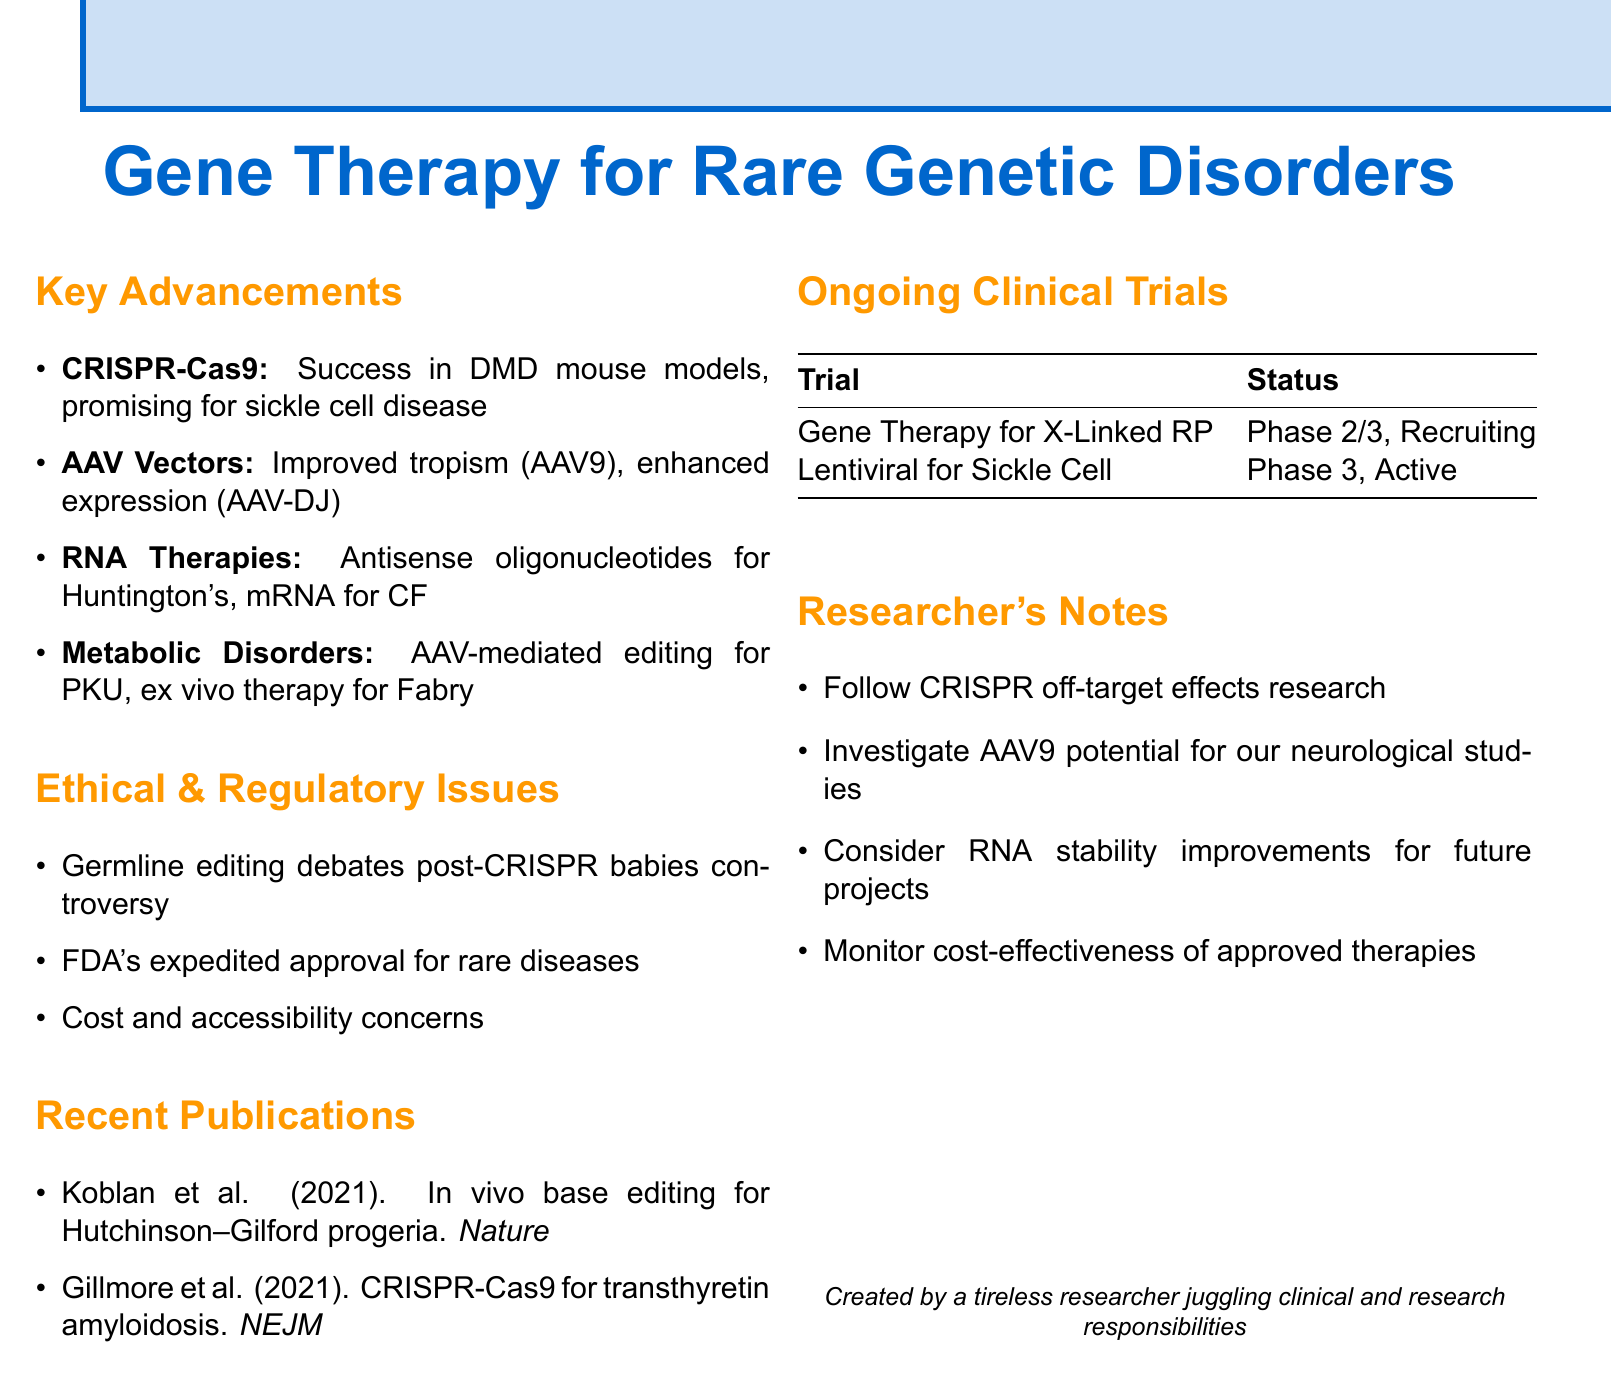What are the recent advancements in gene therapy? The document summarizes key advancements, including CRISPR-Cas9 breakthroughs, AAV vector developments, RNA-based therapies, and gene editing for metabolic disorders.
Answer: CRISPR-Cas9 breakthroughs, AAV vector developments, RNA-based therapies, gene editing for metabolic disorders What is the title of the publication by Koblan et al.? The document lists a recent publication by Koblan et al. from 2021 focused on gene therapy.
Answer: In vivo base editing rescues Hutchinson–Gilford progeria syndrome in mice Which company sponsors the trial for gene therapy of X-Linked Retinitis Pigmentosa? The document provides details on ongoing clinical trials, including sponsorship information.
Answer: Nightstar Therapeutics What is the phase of the trial for Lentiviral Gene Therapy for Sickle Cell Disease? The document specifies the phase information of the ongoing clinical trial.
Answer: Phase 3 What are the ethical considerations mentioned? The document outlines key ethical issues in gene therapy, emphasizing current debates.
Answer: Germline gene editing debates, FDA's expedited approval pathways, cost concerns What improvement is expected in mRNA therapeutics for cystic fibrosis? The document mentions specific treatments and their challenges, including expected improvements.
Answer: Entering clinical trials Which condition is associated with AAV-mediated gene editing as highlighted in the document? The detail is derived from the section on metabolic disorders and gene editing advancements.
Answer: Phenylketonuria (PKU) What recent FDA approval is specifically mentioned? The document lists significant advancements, including approvals relevant to gene therapy.
Answer: Zolgensma for spinal muscular atrophy (SMA) What is the status of the Gene Therapy for X-Linked Retinitis Pigmentosa trial? The document describes the recruitment status for ongoing clinical trials.
Answer: Recruiting 